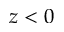Convert formula to latex. <formula><loc_0><loc_0><loc_500><loc_500>z < 0</formula> 